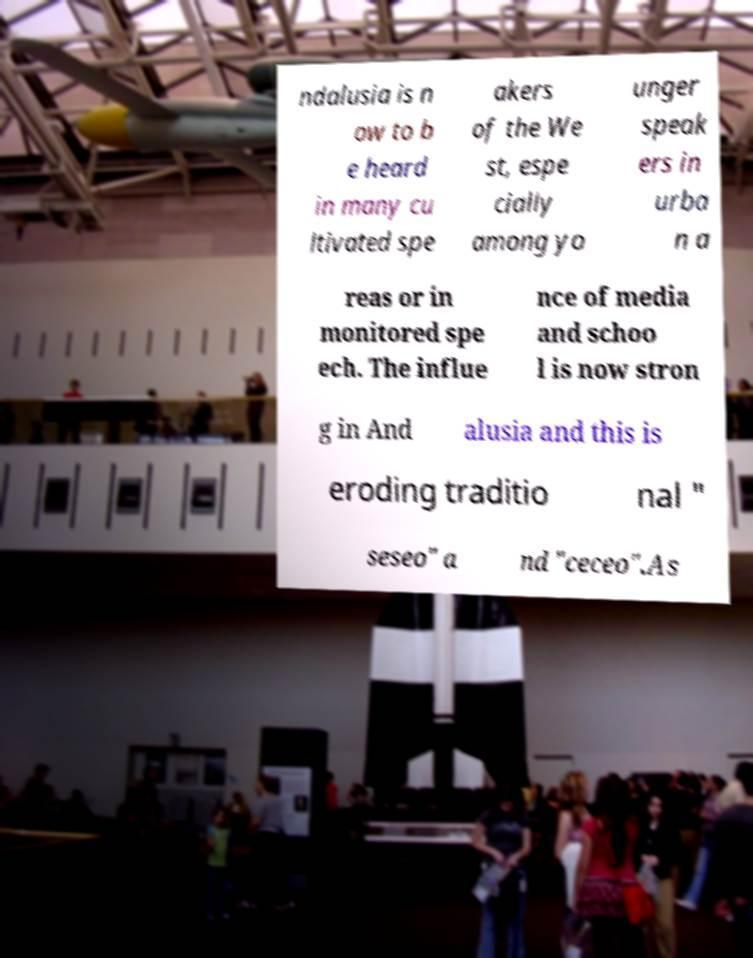Please read and relay the text visible in this image. What does it say? ndalusia is n ow to b e heard in many cu ltivated spe akers of the We st, espe cially among yo unger speak ers in urba n a reas or in monitored spe ech. The influe nce of media and schoo l is now stron g in And alusia and this is eroding traditio nal " seseo" a nd "ceceo".As 